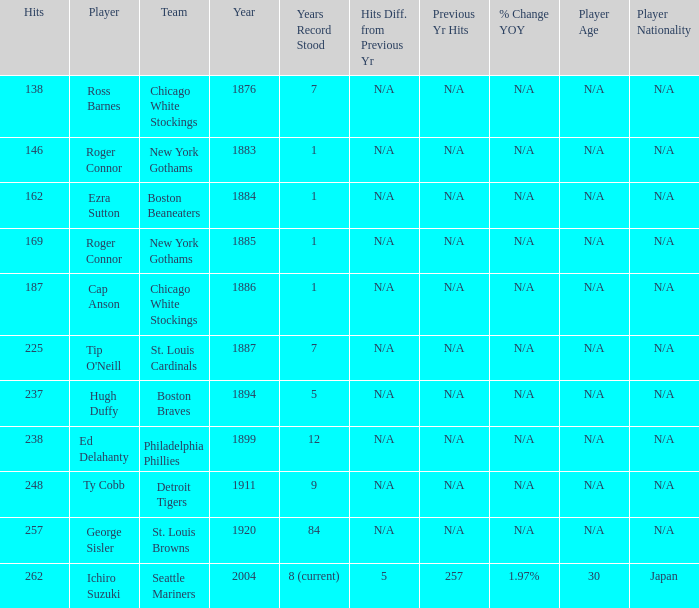Name the player with 238 hits and years after 1885 Ed Delahanty. 